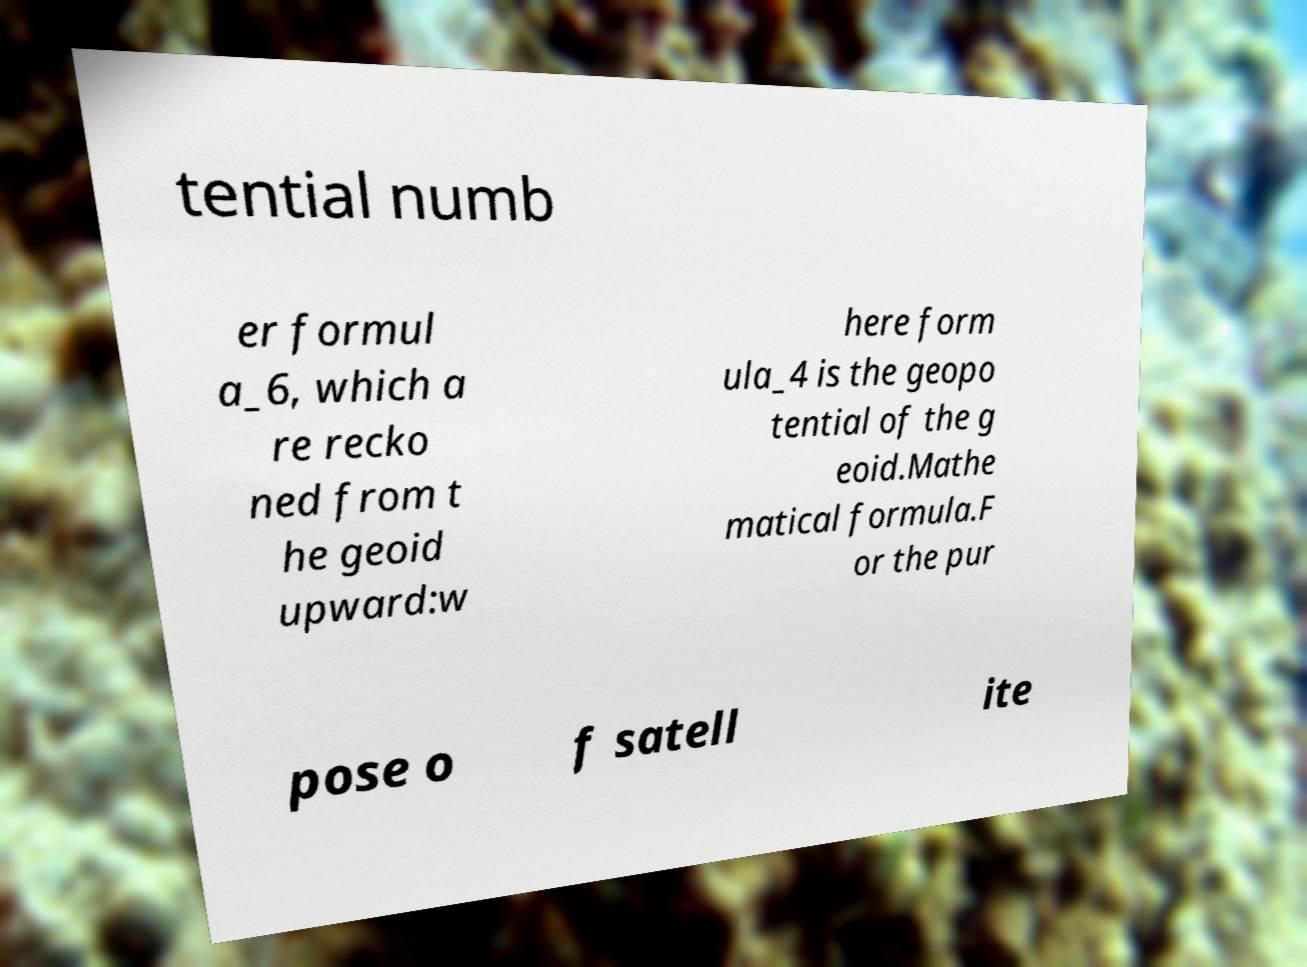There's text embedded in this image that I need extracted. Can you transcribe it verbatim? tential numb er formul a_6, which a re recko ned from t he geoid upward:w here form ula_4 is the geopo tential of the g eoid.Mathe matical formula.F or the pur pose o f satell ite 